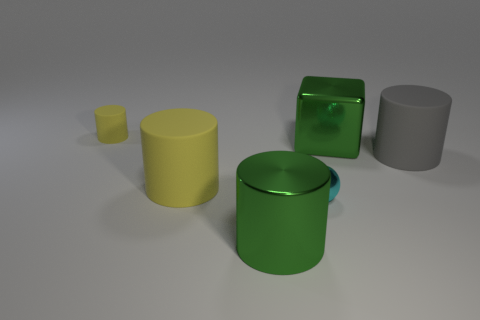Does the yellow rubber thing that is in front of the small yellow object have the same size as the metallic thing that is behind the gray cylinder?
Provide a short and direct response. Yes. What color is the big rubber object left of the large gray object?
Your answer should be compact. Yellow. Are there fewer cylinders in front of the small cyan ball than big shiny things?
Your response must be concise. Yes. Do the ball and the large gray cylinder have the same material?
Keep it short and to the point. No. What size is the other yellow rubber thing that is the same shape as the large yellow rubber thing?
Provide a succinct answer. Small. How many objects are big green things behind the large gray object or shiny things behind the tiny cyan metallic ball?
Ensure brevity in your answer.  1. Is the number of big metallic blocks less than the number of big gray matte balls?
Your response must be concise. No. Do the gray rubber thing and the metallic ball left of the green metallic block have the same size?
Your answer should be compact. No. How many shiny objects are either tiny green things or tiny yellow objects?
Ensure brevity in your answer.  0. Is the number of big green things greater than the number of cyan objects?
Provide a short and direct response. Yes. 